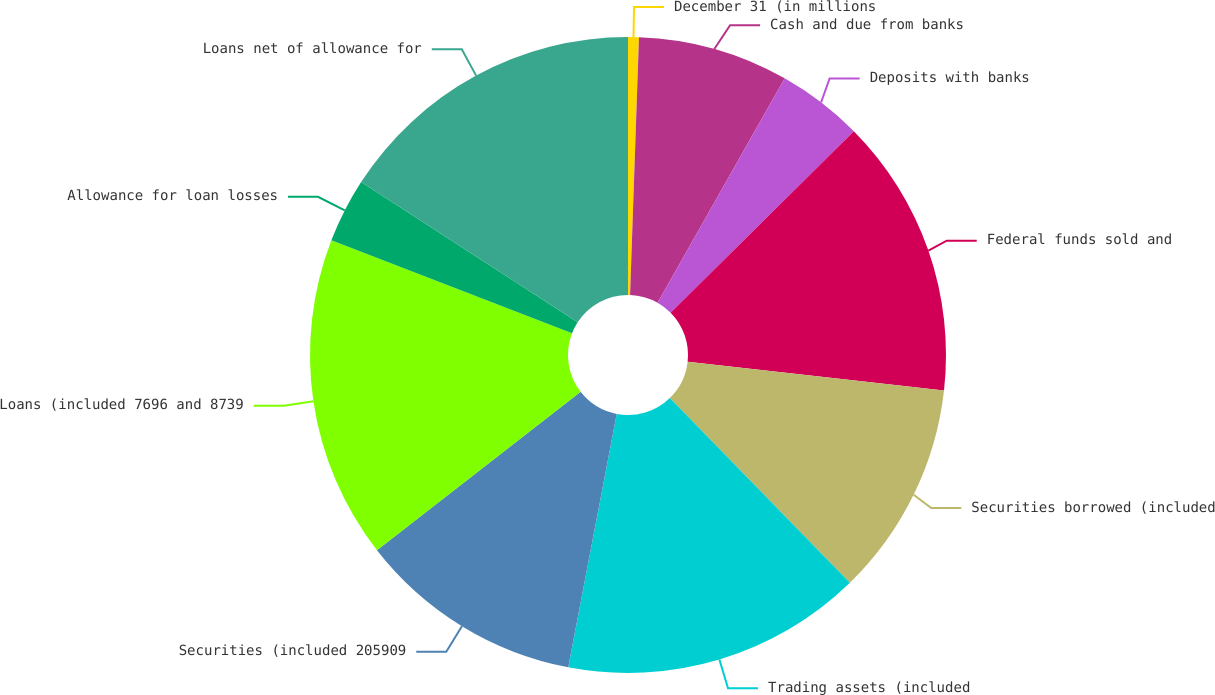Convert chart. <chart><loc_0><loc_0><loc_500><loc_500><pie_chart><fcel>December 31 (in millions<fcel>Cash and due from banks<fcel>Deposits with banks<fcel>Federal funds sold and<fcel>Securities borrowed (included<fcel>Trading assets (included<fcel>Securities (included 205909<fcel>Loans (included 7696 and 8739<fcel>Allowance for loan losses<fcel>Loans net of allowance for<nl><fcel>0.55%<fcel>7.65%<fcel>4.37%<fcel>14.21%<fcel>10.93%<fcel>15.3%<fcel>11.47%<fcel>16.39%<fcel>3.28%<fcel>15.85%<nl></chart> 